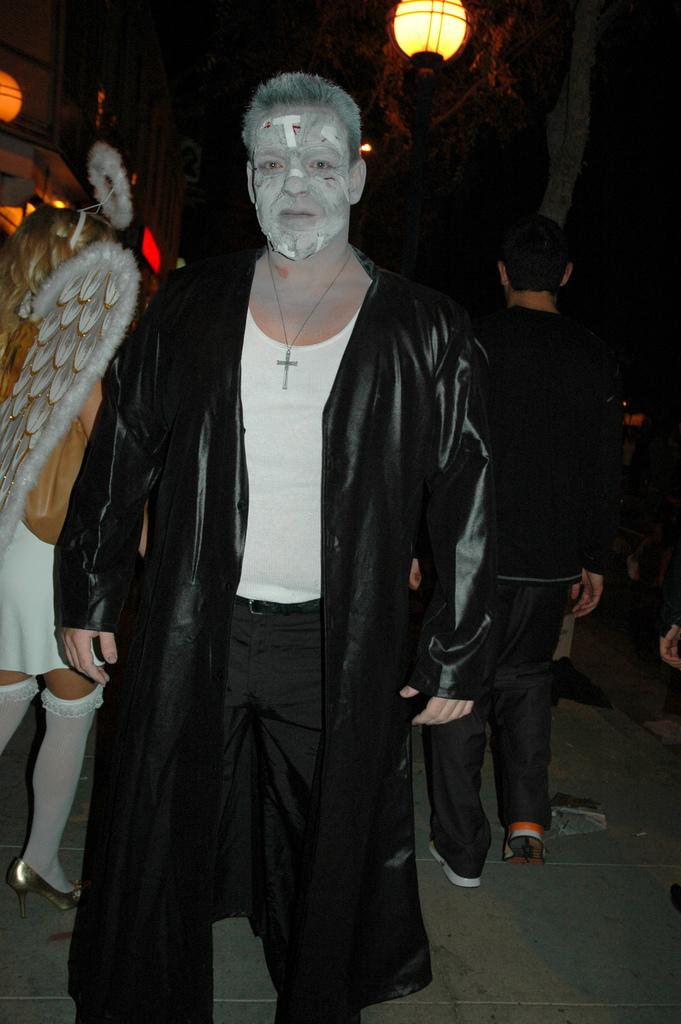What are the people in the image wearing? The people in the image are wearing costumes. Can you describe any other elements in the image? Yes, there are lights visible in the image. What type of pipe is being used by the people in the image? There is no pipe present in the image; the people are wearing costumes and there are lights visible. 